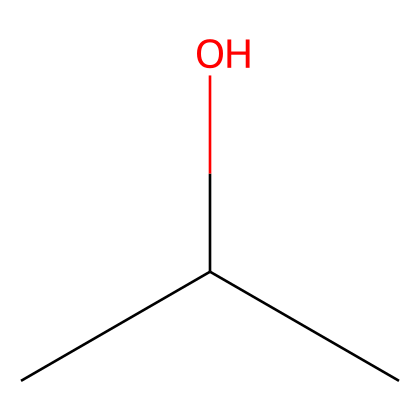What is the name of this chemical? The SMILES representation "CC(C)O" corresponds to isopropyl alcohol, which is a common name for this compound.
Answer: isopropyl alcohol How many carbon atoms are in isopropyl alcohol? The structure "CC(C)O" shows three carbon atoms denoted by the 'C's in the SMILES notation.
Answer: three How many hydrogen atoms are present in isopropyl alcohol? Each carbon in isopropyl alcohol is bonded to enough hydrogen atoms to make four total bonds for each carbon. Therefore, there are a total of eight hydrogen atoms.
Answer: eight What functional group is present in isopropyl alcohol? The "O" in the SMILES "CC(C)O" indicates the presence of a hydroxyl (-OH) functional group, which is characteristic of alcohols.
Answer: hydroxyl What type of chemical bond is primarily found in isopropyl alcohol? The primary chemical bonds in isopropyl alcohol are covalent bonds, as it consists of non-metal atoms sharing electrons.
Answer: covalent Is isopropyl alcohol considered a flammable liquid? Isopropyl alcohol is known for its flammable properties, particularly in concentrations greater than 60% when exposed to heat or flame.
Answer: yes What is the primary use of isopropyl alcohol in pharmaceutical labs? Isopropyl alcohol is commonly used as a disinfectant due to its ability to kill bacteria and viruses effectively.
Answer: disinfectant 